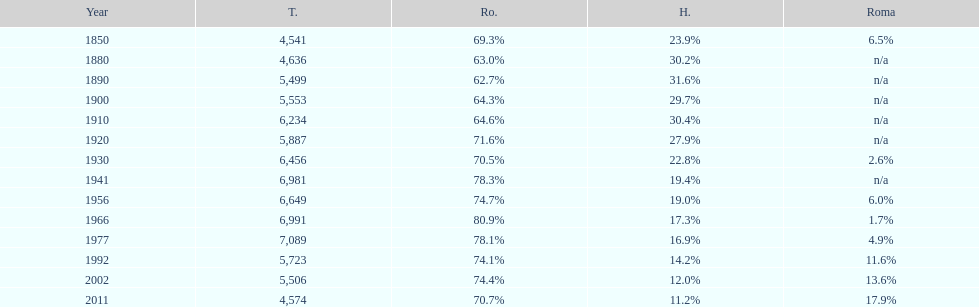In which year were there 6,981 and 1 1941. 